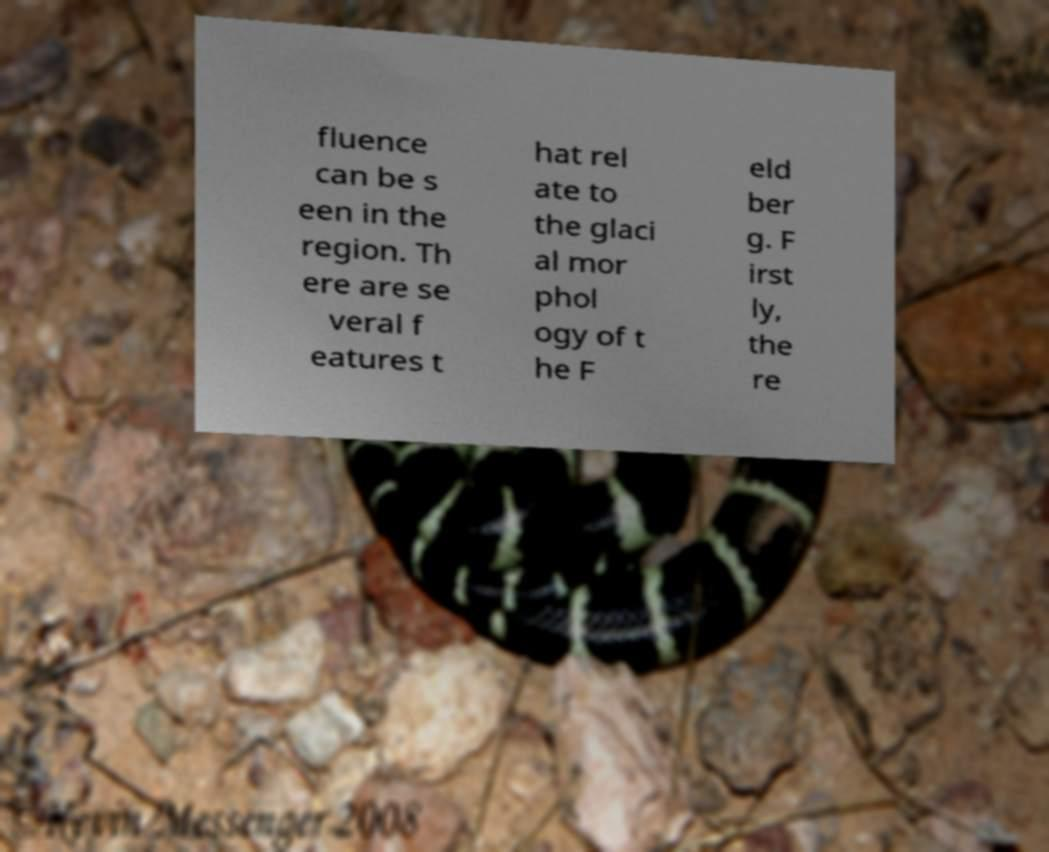Could you extract and type out the text from this image? fluence can be s een in the region. Th ere are se veral f eatures t hat rel ate to the glaci al mor phol ogy of t he F eld ber g. F irst ly, the re 